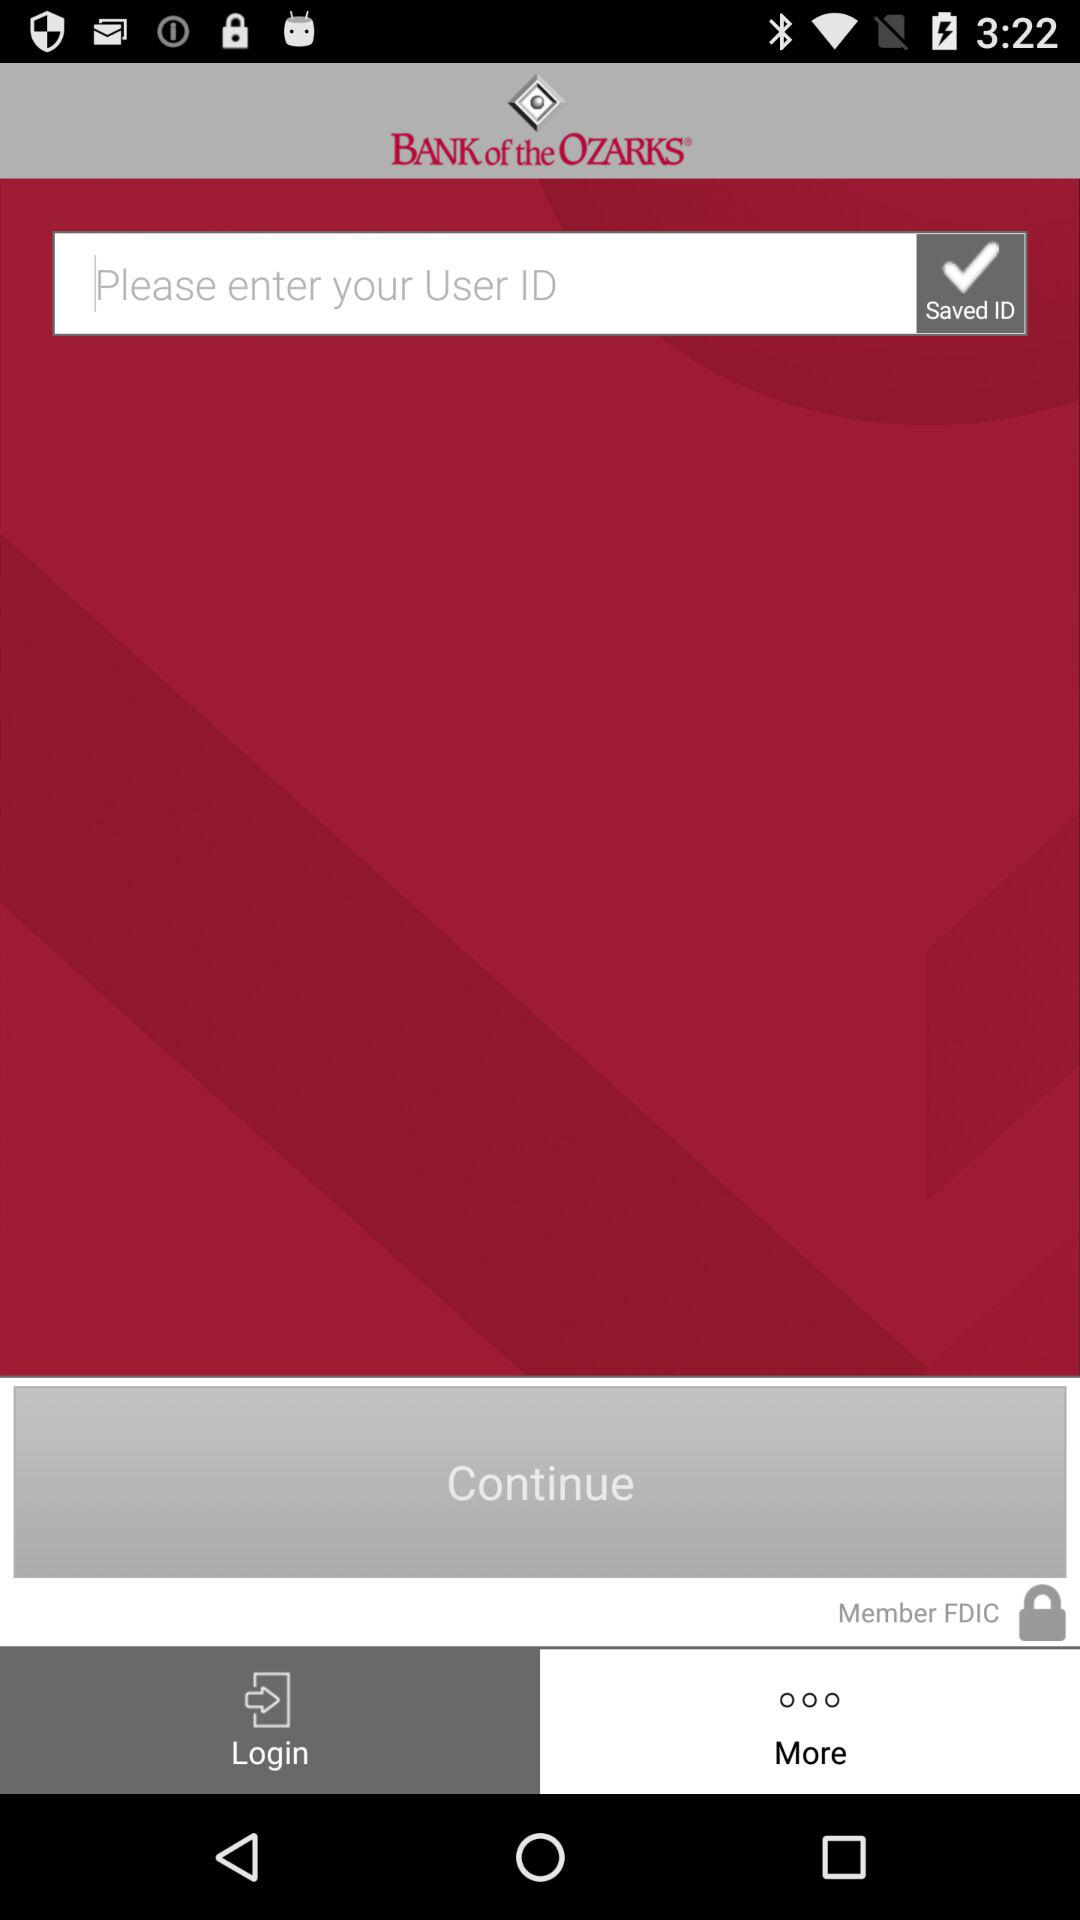What is the application name? The application name is "BANK of the OZARKS". 